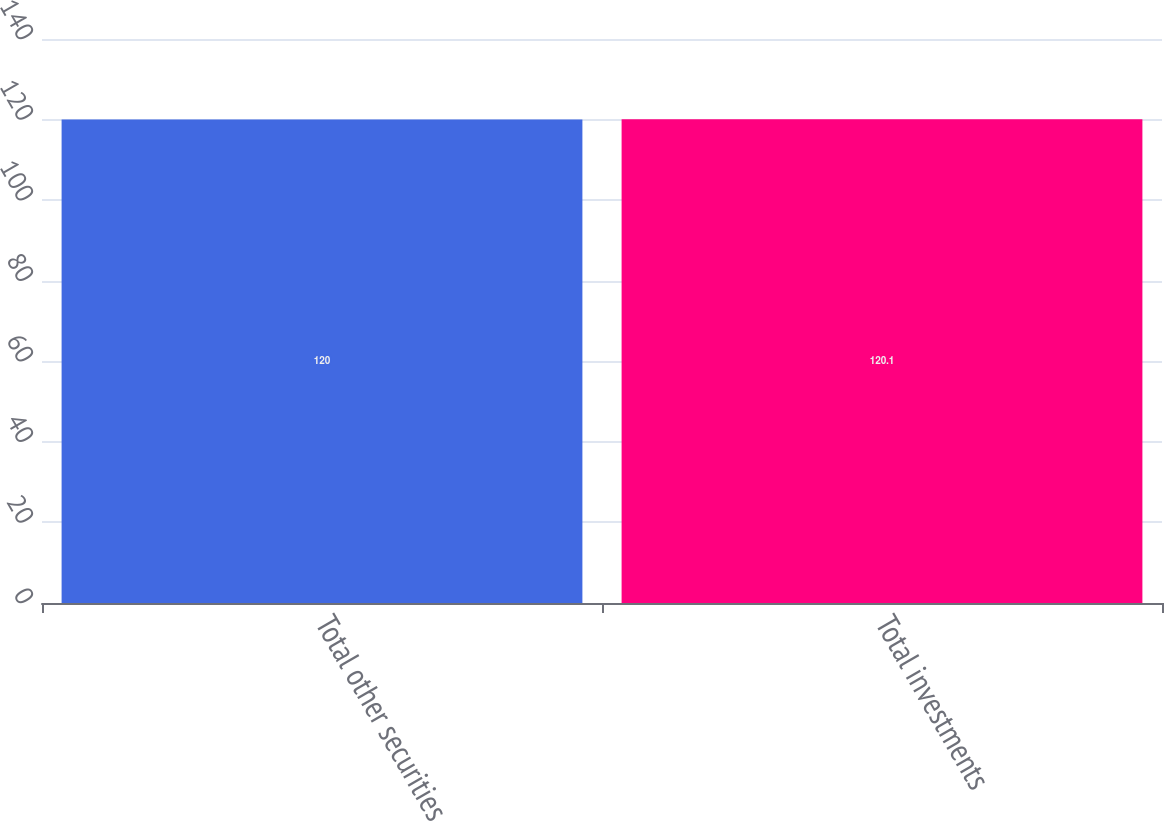Convert chart. <chart><loc_0><loc_0><loc_500><loc_500><bar_chart><fcel>Total other securities<fcel>Total investments<nl><fcel>120<fcel>120.1<nl></chart> 